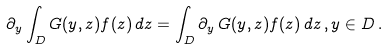Convert formula to latex. <formula><loc_0><loc_0><loc_500><loc_500>\partial _ { y } \int _ { D } G ( y , z ) f ( z ) \, d z = \int _ { D } \partial _ { y } \, G ( y , z ) f ( z ) \, d z \, , y \in D \, .</formula> 